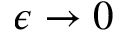Convert formula to latex. <formula><loc_0><loc_0><loc_500><loc_500>\epsilon \to 0</formula> 